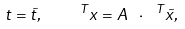<formula> <loc_0><loc_0><loc_500><loc_500>t = { \tilde { t } } , \quad ^ { T } x = A \text { } \cdot \text { } ^ { T } { \tilde { x } } ,</formula> 